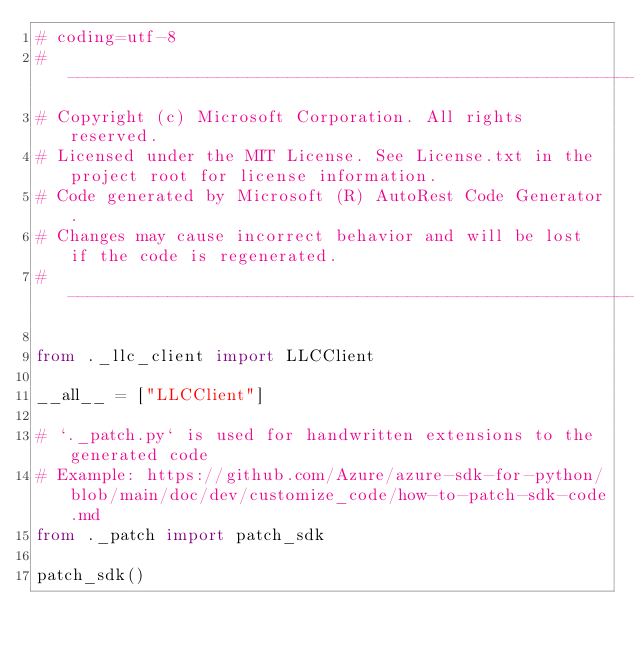Convert code to text. <code><loc_0><loc_0><loc_500><loc_500><_Python_># coding=utf-8
# --------------------------------------------------------------------------
# Copyright (c) Microsoft Corporation. All rights reserved.
# Licensed under the MIT License. See License.txt in the project root for license information.
# Code generated by Microsoft (R) AutoRest Code Generator.
# Changes may cause incorrect behavior and will be lost if the code is regenerated.
# --------------------------------------------------------------------------

from ._llc_client import LLCClient

__all__ = ["LLCClient"]

# `._patch.py` is used for handwritten extensions to the generated code
# Example: https://github.com/Azure/azure-sdk-for-python/blob/main/doc/dev/customize_code/how-to-patch-sdk-code.md
from ._patch import patch_sdk

patch_sdk()
</code> 